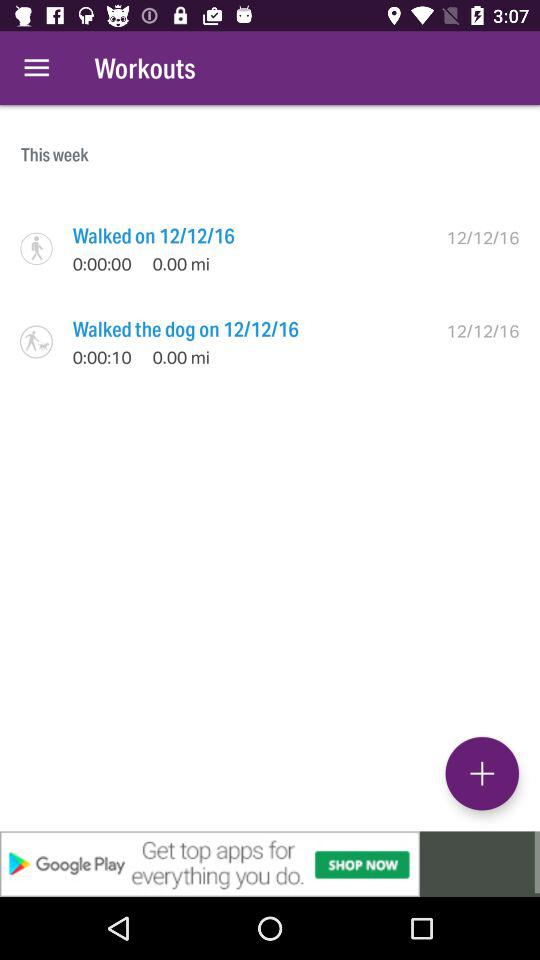How many workouts were completed this week?
Answer the question using a single word or phrase. 2 